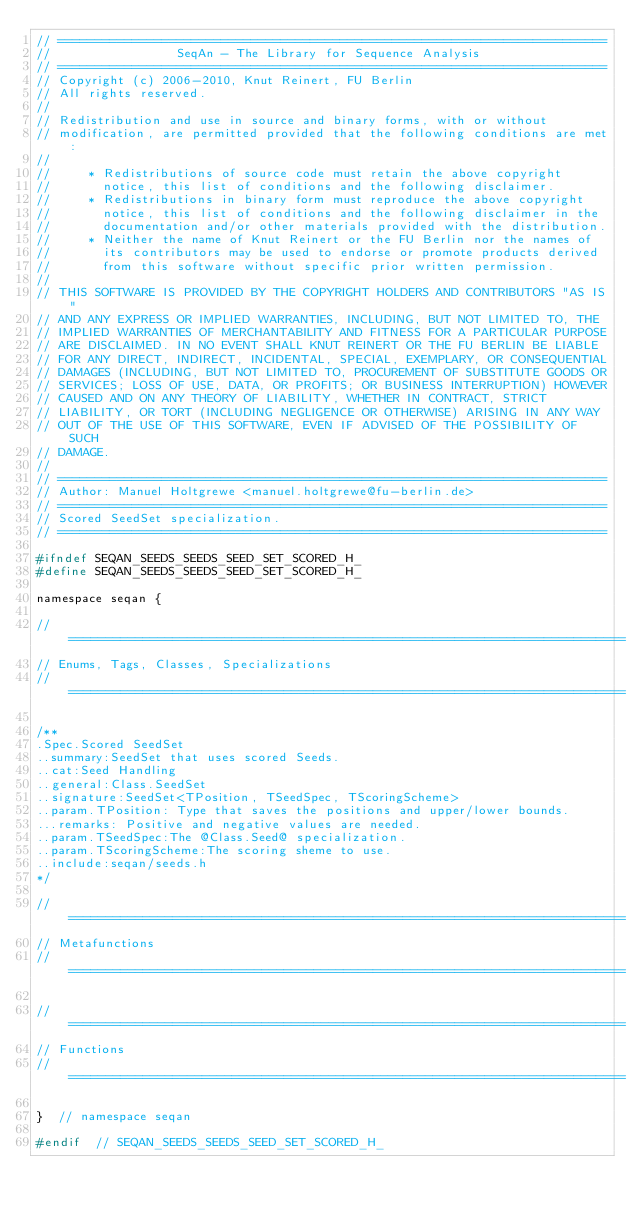Convert code to text. <code><loc_0><loc_0><loc_500><loc_500><_C_>// ==========================================================================
//                 SeqAn - The Library for Sequence Analysis
// ==========================================================================
// Copyright (c) 2006-2010, Knut Reinert, FU Berlin
// All rights reserved.
//
// Redistribution and use in source and binary forms, with or without
// modification, are permitted provided that the following conditions are met:
//
//     * Redistributions of source code must retain the above copyright
//       notice, this list of conditions and the following disclaimer.
//     * Redistributions in binary form must reproduce the above copyright
//       notice, this list of conditions and the following disclaimer in the
//       documentation and/or other materials provided with the distribution.
//     * Neither the name of Knut Reinert or the FU Berlin nor the names of
//       its contributors may be used to endorse or promote products derived
//       from this software without specific prior written permission.
//
// THIS SOFTWARE IS PROVIDED BY THE COPYRIGHT HOLDERS AND CONTRIBUTORS "AS IS"
// AND ANY EXPRESS OR IMPLIED WARRANTIES, INCLUDING, BUT NOT LIMITED TO, THE
// IMPLIED WARRANTIES OF MERCHANTABILITY AND FITNESS FOR A PARTICULAR PURPOSE
// ARE DISCLAIMED. IN NO EVENT SHALL KNUT REINERT OR THE FU BERLIN BE LIABLE
// FOR ANY DIRECT, INDIRECT, INCIDENTAL, SPECIAL, EXEMPLARY, OR CONSEQUENTIAL
// DAMAGES (INCLUDING, BUT NOT LIMITED TO, PROCUREMENT OF SUBSTITUTE GOODS OR
// SERVICES; LOSS OF USE, DATA, OR PROFITS; OR BUSINESS INTERRUPTION) HOWEVER
// CAUSED AND ON ANY THEORY OF LIABILITY, WHETHER IN CONTRACT, STRICT
// LIABILITY, OR TORT (INCLUDING NEGLIGENCE OR OTHERWISE) ARISING IN ANY WAY
// OUT OF THE USE OF THIS SOFTWARE, EVEN IF ADVISED OF THE POSSIBILITY OF SUCH
// DAMAGE.
//
// ==========================================================================
// Author: Manuel Holtgrewe <manuel.holtgrewe@fu-berlin.de>
// ==========================================================================
// Scored SeedSet specialization.
// ==========================================================================

#ifndef SEQAN_SEEDS_SEEDS_SEED_SET_SCORED_H_
#define SEQAN_SEEDS_SEEDS_SEED_SET_SCORED_H_

namespace seqan {

// ===========================================================================
// Enums, Tags, Classes, Specializations
// ===========================================================================

/**
.Spec.Scored SeedSet
..summary:SeedSet that uses scored Seeds.
..cat:Seed Handling
..general:Class.SeedSet
..signature:SeedSet<TPosition, TSeedSpec, TScoringScheme>
..param.TPosition: Type that saves the positions and upper/lower bounds.
...remarks: Positive and negative values are needed.
..param.TSeedSpec:The @Class.Seed@ specialization.
..param.TScoringScheme:The scoring sheme to use.
..include:seqan/seeds.h
*/

// ===========================================================================
// Metafunctions
// ===========================================================================

// ===========================================================================
// Functions
// ===========================================================================

}  // namespace seqan

#endif  // SEQAN_SEEDS_SEEDS_SEED_SET_SCORED_H_
</code> 